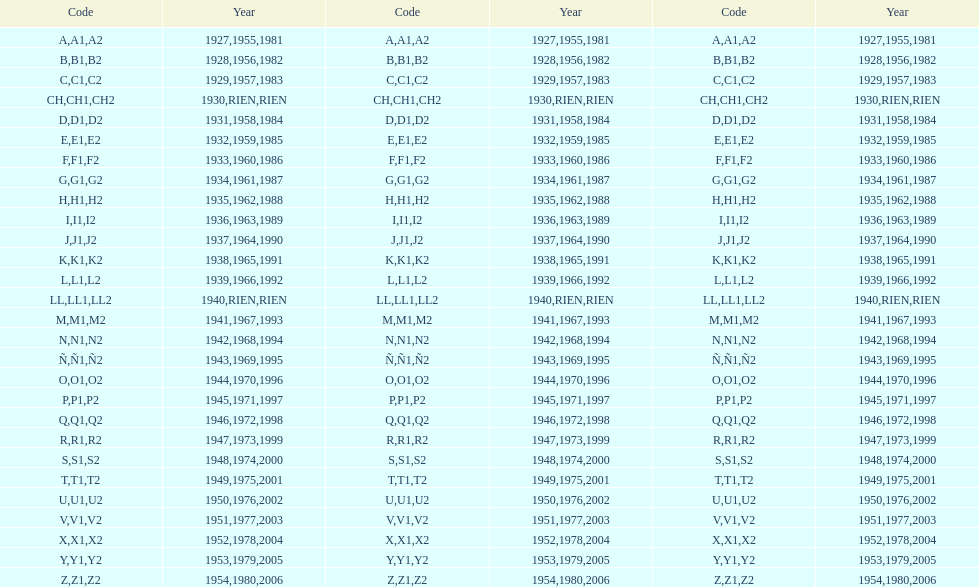Besides 1927, in which year did the code commence with an a? 1955, 1981. 